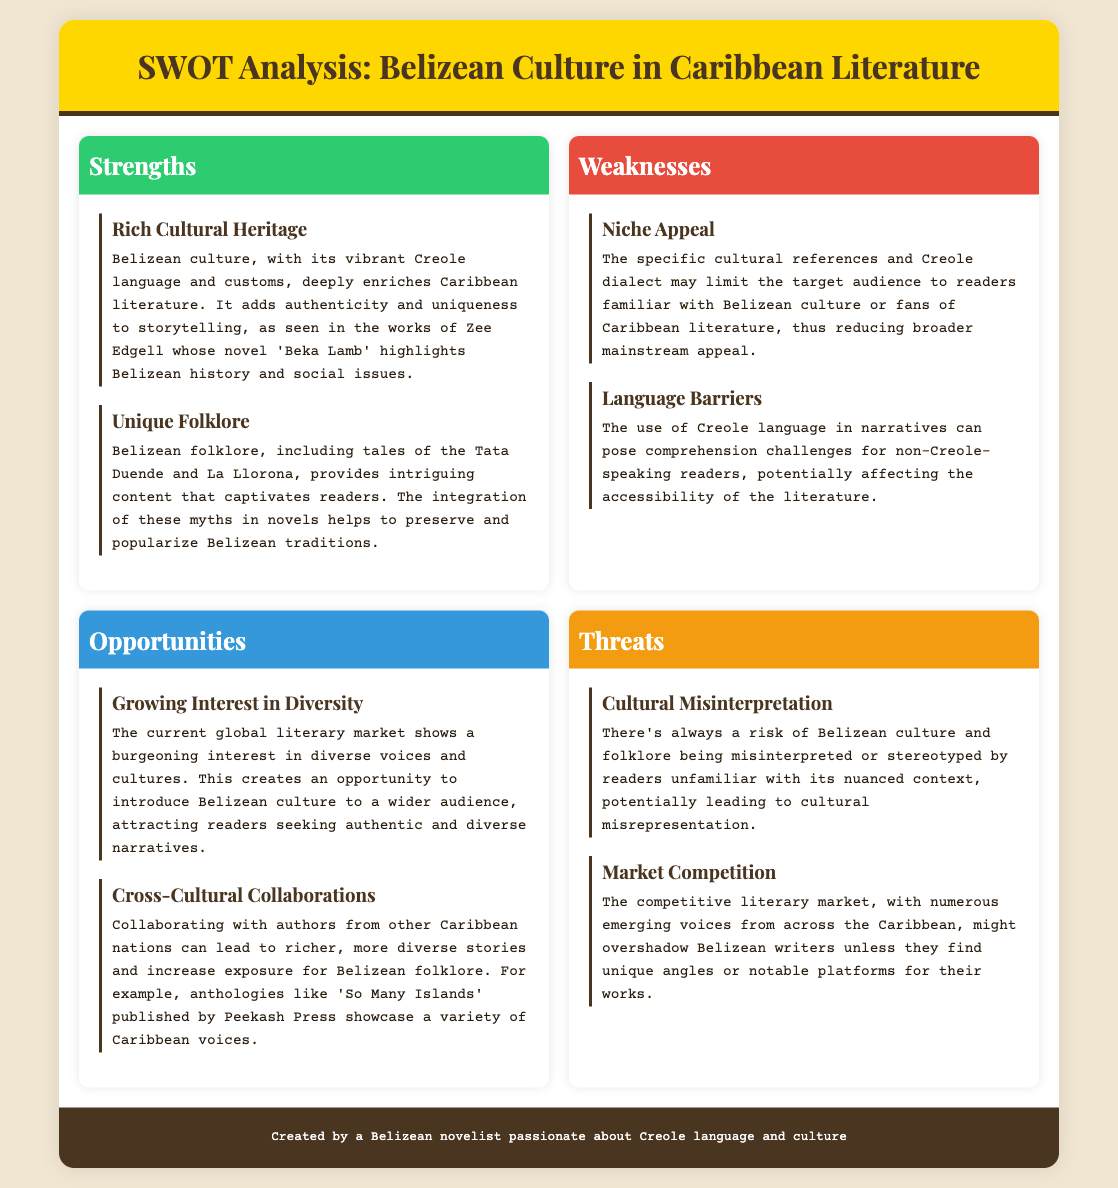what is one strength of Belizean culture in literature? The document mentions that Belizean culture adds authenticity and uniqueness to storytelling in Caribbean literature, highlighting its rich cultural heritage.
Answer: Rich Cultural Heritage what is a weakness related to language in Belizean literature? The document states that the use of Creole language in narratives can affect accessibility for non-Creole-speaking readers.
Answer: Language Barriers what opportunity is mentioned in the document regarding global interest? The analysis notes a growing interest in diverse voices and cultures in the literary market, creating opportunities for Belizean culture.
Answer: Growing Interest in Diversity what threat is associated with cultural misinterpretation? The document highlights the risk of Belizean culture being misinterpreted or stereotyped by readers unfamiliar with its context.
Answer: Cultural Misinterpretation who is a notable Belizean author mentioned in the strengths section? The document cites Zee Edgell as an example of a Belizean author whose work enriches Caribbean literature.
Answer: Zee Edgell what is one unique aspect of Belizean folklore? The SWOT analysis identifies tales of Tata Duende and La Llorona as examples of Belizean folklore that captivates readers.
Answer: Tata Duende how can cross-cultural collaborations benefit Belizean literature? The document explains that collaborating with authors from other Caribbean nations can enrich stories and increase exposure for Belizean folklore.
Answer: Increase exposure for Belizean folklore what competes with Belizean writers in the literary market? According to the analysis, the competitive literary market with numerous emerging voices poses a challenge for Belizean writers.
Answer: Market Competition 